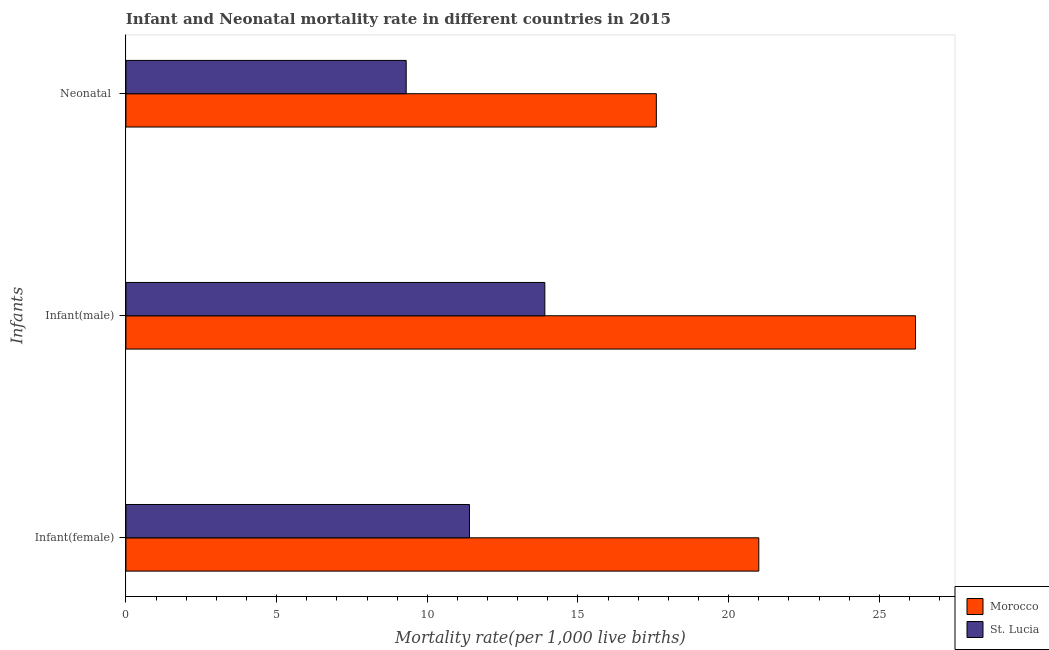How many bars are there on the 3rd tick from the bottom?
Provide a succinct answer. 2. What is the label of the 2nd group of bars from the top?
Your answer should be compact. Infant(male). What is the infant mortality rate(male) in St. Lucia?
Offer a very short reply. 13.9. Across all countries, what is the maximum infant mortality rate(male)?
Offer a terse response. 26.2. In which country was the infant mortality rate(female) maximum?
Give a very brief answer. Morocco. In which country was the infant mortality rate(female) minimum?
Give a very brief answer. St. Lucia. What is the total neonatal mortality rate in the graph?
Ensure brevity in your answer.  26.9. What is the difference between the infant mortality rate(male) in St. Lucia and that in Morocco?
Give a very brief answer. -12.3. What is the difference between the infant mortality rate(male) in St. Lucia and the neonatal mortality rate in Morocco?
Provide a succinct answer. -3.7. What is the average neonatal mortality rate per country?
Your answer should be very brief. 13.45. What is the difference between the neonatal mortality rate and infant mortality rate(male) in Morocco?
Your answer should be very brief. -8.6. In how many countries, is the neonatal mortality rate greater than 7 ?
Provide a succinct answer. 2. What is the ratio of the infant mortality rate(male) in Morocco to that in St. Lucia?
Offer a very short reply. 1.88. What is the difference between the highest and the second highest infant mortality rate(male)?
Provide a short and direct response. 12.3. In how many countries, is the neonatal mortality rate greater than the average neonatal mortality rate taken over all countries?
Make the answer very short. 1. Is the sum of the infant mortality rate(male) in St. Lucia and Morocco greater than the maximum infant mortality rate(female) across all countries?
Your answer should be very brief. Yes. What does the 2nd bar from the top in Infant(female) represents?
Your response must be concise. Morocco. What does the 1st bar from the bottom in Infant(male) represents?
Offer a terse response. Morocco. How many bars are there?
Offer a very short reply. 6. Are all the bars in the graph horizontal?
Ensure brevity in your answer.  Yes. How many countries are there in the graph?
Your response must be concise. 2. What is the difference between two consecutive major ticks on the X-axis?
Provide a short and direct response. 5. Are the values on the major ticks of X-axis written in scientific E-notation?
Offer a terse response. No. Does the graph contain grids?
Ensure brevity in your answer.  No. Where does the legend appear in the graph?
Give a very brief answer. Bottom right. What is the title of the graph?
Give a very brief answer. Infant and Neonatal mortality rate in different countries in 2015. What is the label or title of the X-axis?
Your answer should be compact. Mortality rate(per 1,0 live births). What is the label or title of the Y-axis?
Offer a terse response. Infants. What is the Mortality rate(per 1,000 live births) of Morocco in Infant(female)?
Make the answer very short. 21. What is the Mortality rate(per 1,000 live births) of St. Lucia in Infant(female)?
Your answer should be very brief. 11.4. What is the Mortality rate(per 1,000 live births) in Morocco in Infant(male)?
Make the answer very short. 26.2. What is the Mortality rate(per 1,000 live births) of St. Lucia in Neonatal ?
Your answer should be compact. 9.3. Across all Infants, what is the maximum Mortality rate(per 1,000 live births) of Morocco?
Your response must be concise. 26.2. Across all Infants, what is the minimum Mortality rate(per 1,000 live births) of Morocco?
Give a very brief answer. 17.6. What is the total Mortality rate(per 1,000 live births) in Morocco in the graph?
Offer a terse response. 64.8. What is the total Mortality rate(per 1,000 live births) of St. Lucia in the graph?
Your answer should be compact. 34.6. What is the difference between the Mortality rate(per 1,000 live births) in Morocco in Infant(female) and that in Neonatal ?
Your response must be concise. 3.4. What is the difference between the Mortality rate(per 1,000 live births) in Morocco in Infant(male) and that in Neonatal ?
Keep it short and to the point. 8.6. What is the difference between the Mortality rate(per 1,000 live births) of St. Lucia in Infant(male) and that in Neonatal ?
Offer a terse response. 4.6. What is the difference between the Mortality rate(per 1,000 live births) of Morocco in Infant(female) and the Mortality rate(per 1,000 live births) of St. Lucia in Neonatal ?
Provide a succinct answer. 11.7. What is the difference between the Mortality rate(per 1,000 live births) of Morocco in Infant(male) and the Mortality rate(per 1,000 live births) of St. Lucia in Neonatal ?
Provide a succinct answer. 16.9. What is the average Mortality rate(per 1,000 live births) in Morocco per Infants?
Give a very brief answer. 21.6. What is the average Mortality rate(per 1,000 live births) in St. Lucia per Infants?
Offer a very short reply. 11.53. What is the difference between the Mortality rate(per 1,000 live births) in Morocco and Mortality rate(per 1,000 live births) in St. Lucia in Infant(female)?
Keep it short and to the point. 9.6. What is the ratio of the Mortality rate(per 1,000 live births) in Morocco in Infant(female) to that in Infant(male)?
Offer a terse response. 0.8. What is the ratio of the Mortality rate(per 1,000 live births) in St. Lucia in Infant(female) to that in Infant(male)?
Offer a very short reply. 0.82. What is the ratio of the Mortality rate(per 1,000 live births) of Morocco in Infant(female) to that in Neonatal ?
Provide a succinct answer. 1.19. What is the ratio of the Mortality rate(per 1,000 live births) in St. Lucia in Infant(female) to that in Neonatal ?
Provide a short and direct response. 1.23. What is the ratio of the Mortality rate(per 1,000 live births) of Morocco in Infant(male) to that in Neonatal ?
Your response must be concise. 1.49. What is the ratio of the Mortality rate(per 1,000 live births) in St. Lucia in Infant(male) to that in Neonatal ?
Ensure brevity in your answer.  1.49. What is the difference between the highest and the second highest Mortality rate(per 1,000 live births) of St. Lucia?
Offer a terse response. 2.5. What is the difference between the highest and the lowest Mortality rate(per 1,000 live births) in Morocco?
Offer a very short reply. 8.6. What is the difference between the highest and the lowest Mortality rate(per 1,000 live births) in St. Lucia?
Your response must be concise. 4.6. 